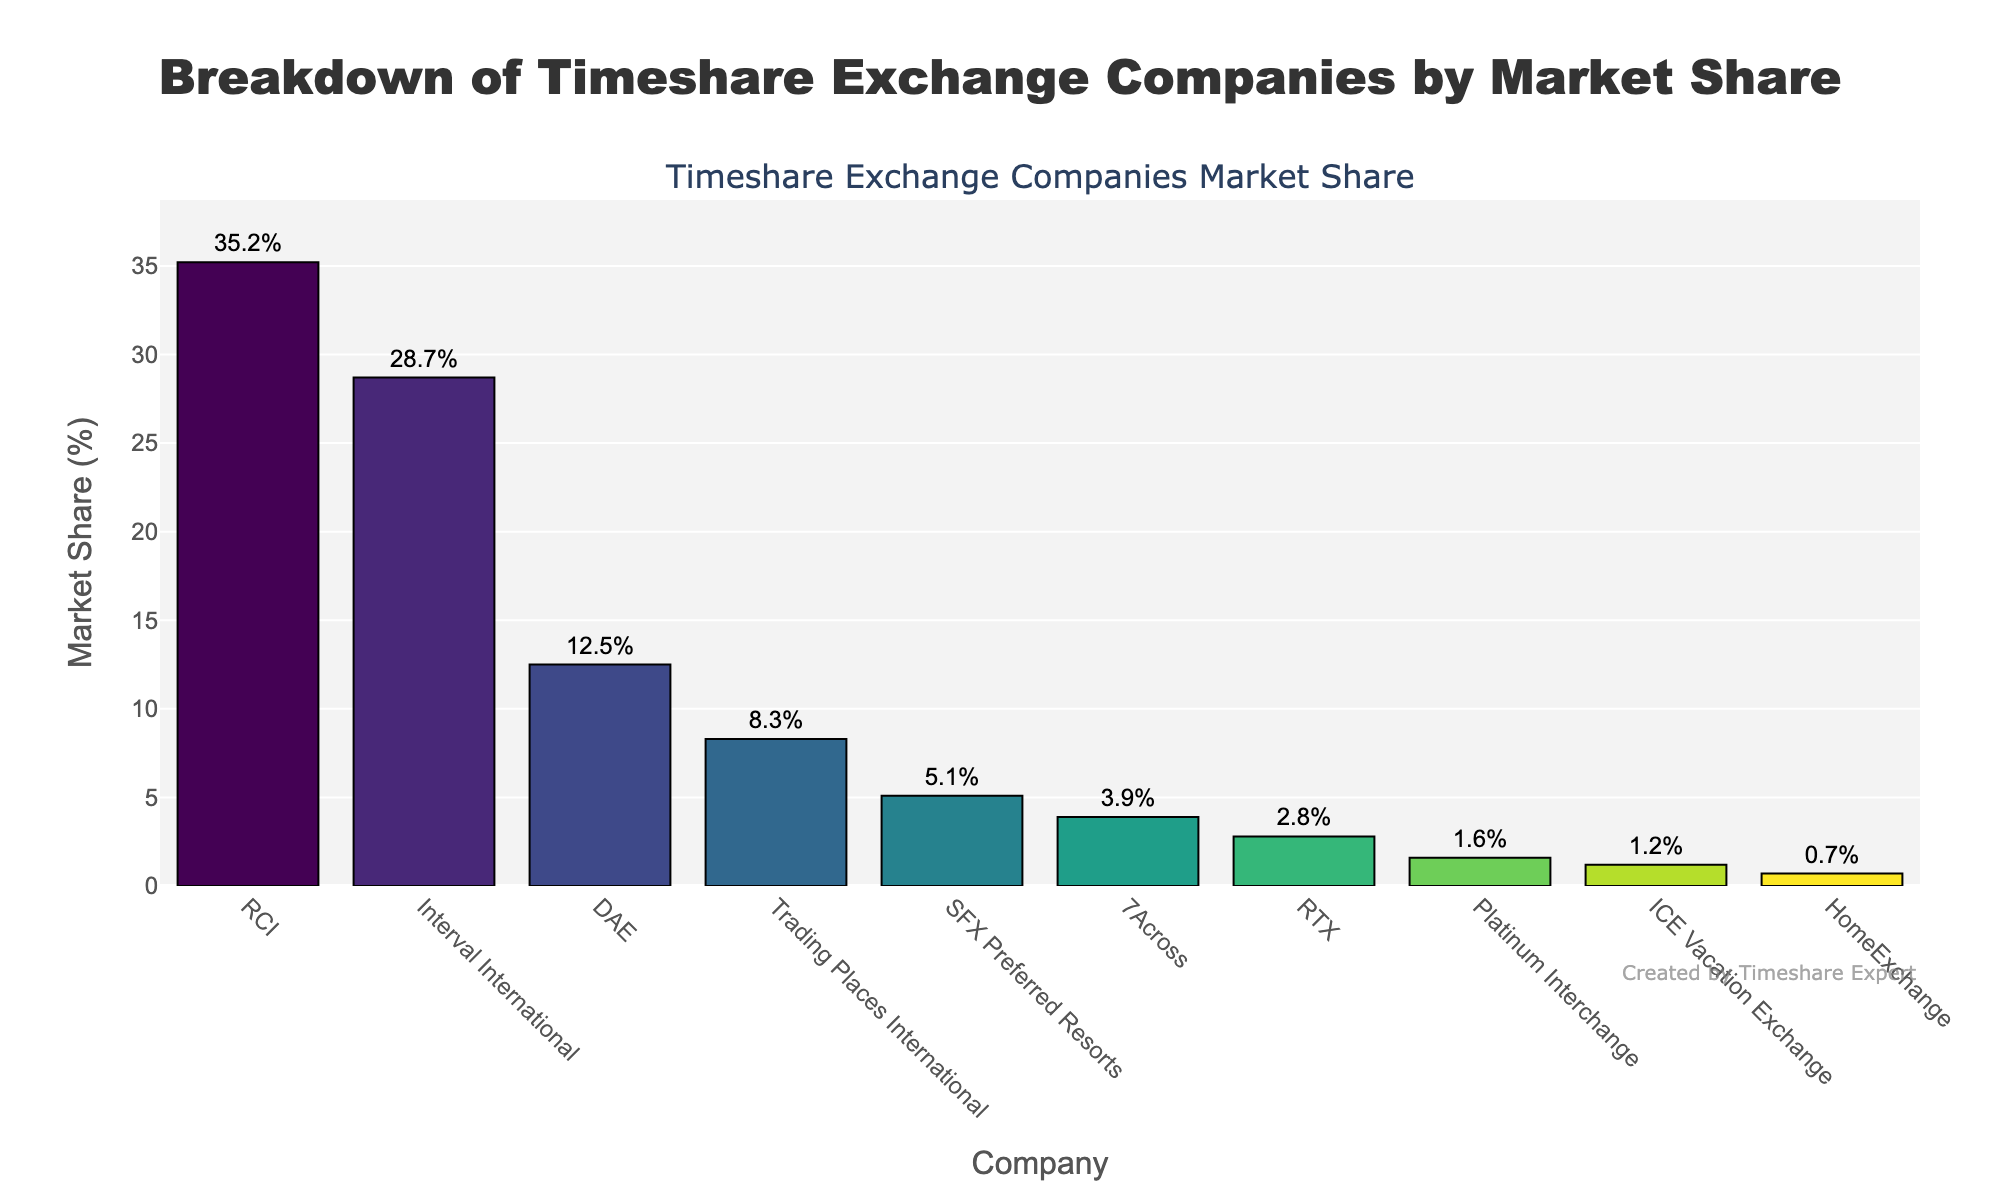What is the company with the largest market share? The company with the highest bar indicates the largest market share. By observing the chart, RCI has the tallest bar. Thus, RCI has the largest market share.
Answer: RCI How much higher is RCI's market share compared to 7Across? First, find the market shares of RCI and 7Across, which are 35.2% and 3.9% respectively. Subtract 7Across's market share from RCI's market share: 35.2% - 3.9% = 31.3%.
Answer: 31.3% Do Interval International and DAE together account for more than half of the market? Calculate their combined market share by adding Interval International's and DAE's market shares: 28.7% + 12.5% = 41.2%. Since 41.2% is less than 50%, they do not account for more than half.
Answer: No, 41.2% What is the total market share of companies with less than 5%? Sum the market shares of all companies with less than 5%: SFX Preferred Resorts (5.1%) is not included, while 7Across (3.9%), RTX (2.8%), Platinum Interchange (1.6%), ICE Vacation Exchange (1.2%), and HomeExchange (0.7%) are included. The sum is 3.9% + 2.8% + 1.6% + 1.2% + 0.7% = 10.2%.
Answer: 10.2% Which company is ranked third by market share? Rank the companies by the heights of their bars. The third tallest bar belongs to DAE indicating it has the third largest market share.
Answer: DAE How many companies have a market share greater than 10%? Count the number of bars with market shares above 10%. RCI (35.2%), Interval International (28.7%), and DAE (12.5%) meet this condition. So, there are 3 companies.
Answer: 3 What is the difference between the market shares of Trading Places International and Platinum Interchange? Subtract Platinum Interchange's market share from Trading Places International's market share: 8.3% - 1.6% = 6.7%.
Answer: 6.7% Among the companies with market shares less than or equal to RTX, which one has the smallest market share? Identify the companies with market shares less than or equal to RTX (2.8%), which are Platinum Interchange (1.6%), ICE Vacation Exchange (1.2%), and HomeExchange (0.7%). HomeExchange has the smallest market share among them.
Answer: HomeExchange What color scheme is used for the bars in the chart? The description indicates a 'Viridis' colorscale is used. By observing the gradient of colors from green to yellow displayed on the bars, this conclusion can be confirmed.
Answer: Viridis colorscale What is the combined market share of the top three companies? Sum the market shares of the top three companies: RCI (35.2%), Interval International (28.7%), and DAE (12.5%). The combined share is 35.2% + 28.7% + 12.5% = 76.4%.
Answer: 76.4% 